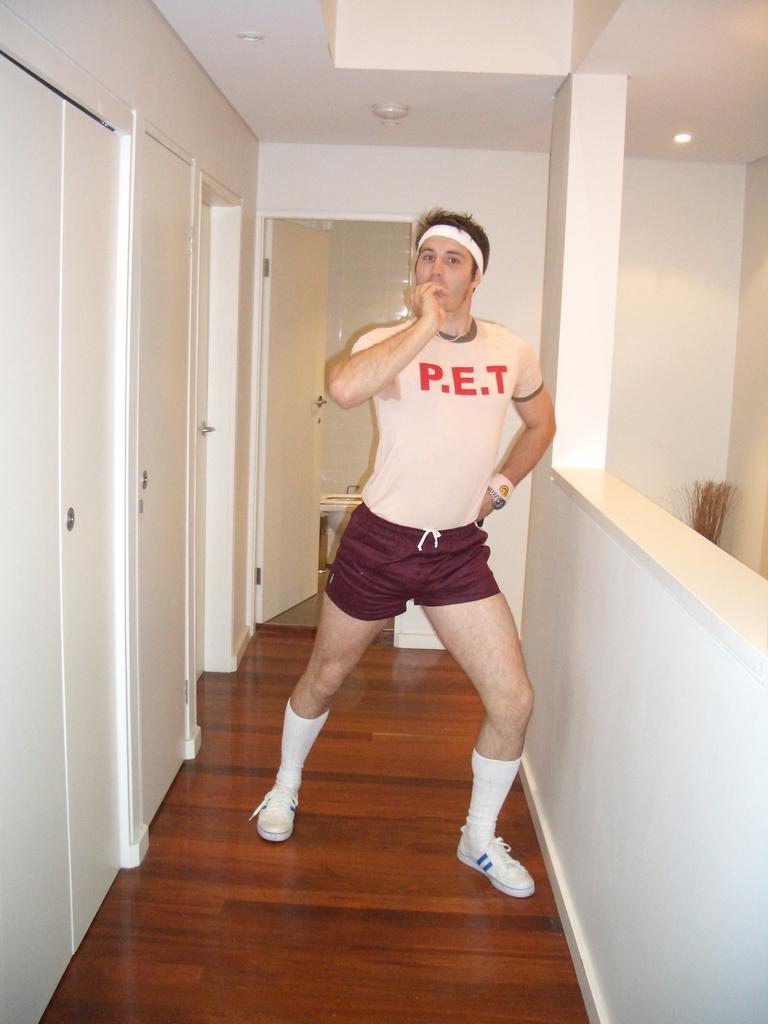<image>
Give a short and clear explanation of the subsequent image. a man that has P.E.T on his shirt 